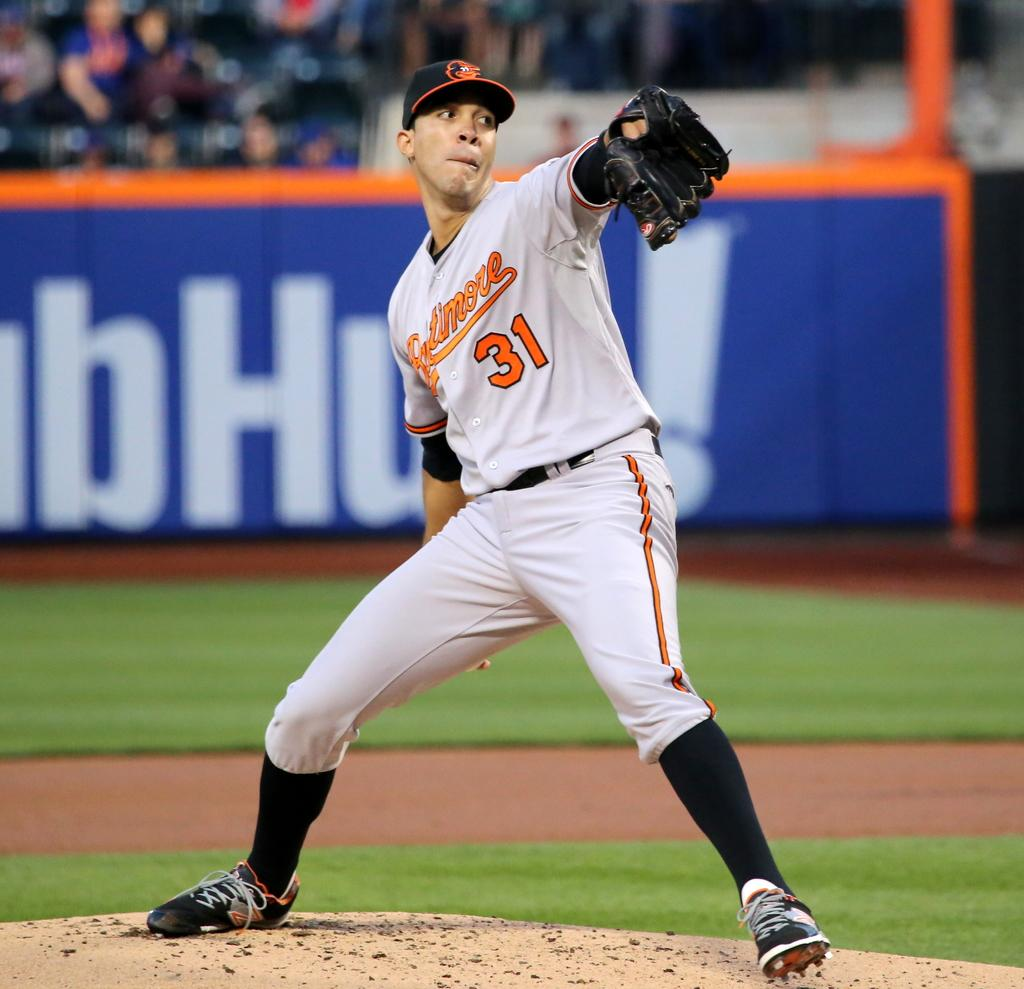<image>
Write a terse but informative summary of the picture. Player 31 from Baltimore is winding up to release a pitch. 